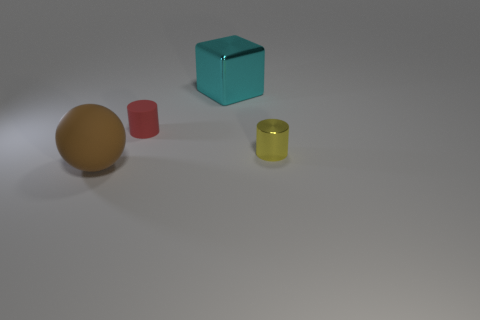If this image is from a game, what genre do you think it might be? If the image were from a game, it could belong to a puzzle or strategy genre. The placement of objects with different shapes and colors suggests an element of organization or problem-solving that is commonly found in puzzle games. It's also possible that it could be an educational game aiming to teach concepts of color, shape, or spatial relationships. 